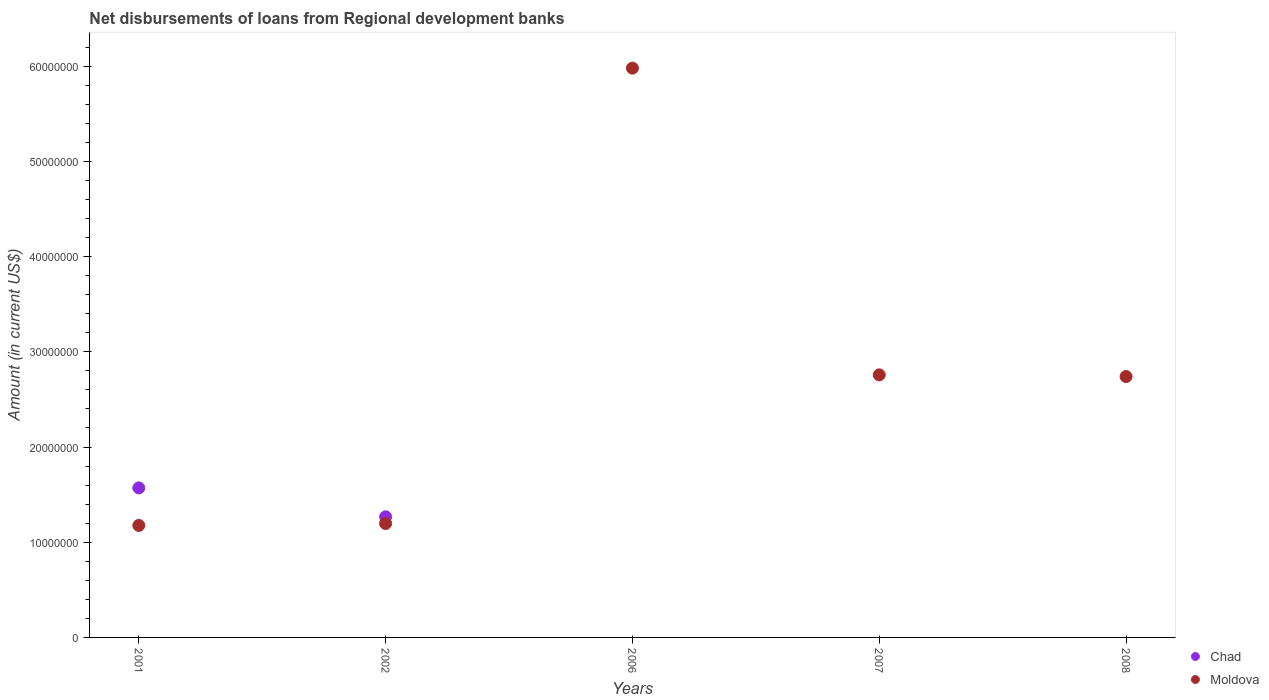Is the number of dotlines equal to the number of legend labels?
Your response must be concise. No. Across all years, what is the maximum amount of disbursements of loans from regional development banks in Moldova?
Your answer should be compact. 5.98e+07. Across all years, what is the minimum amount of disbursements of loans from regional development banks in Moldova?
Make the answer very short. 1.18e+07. What is the total amount of disbursements of loans from regional development banks in Moldova in the graph?
Your response must be concise. 1.39e+08. What is the difference between the amount of disbursements of loans from regional development banks in Chad in 2001 and that in 2002?
Give a very brief answer. 3.04e+06. What is the difference between the amount of disbursements of loans from regional development banks in Chad in 2006 and the amount of disbursements of loans from regional development banks in Moldova in 2002?
Offer a terse response. -1.20e+07. What is the average amount of disbursements of loans from regional development banks in Chad per year?
Ensure brevity in your answer.  5.68e+06. In the year 2002, what is the difference between the amount of disbursements of loans from regional development banks in Moldova and amount of disbursements of loans from regional development banks in Chad?
Your answer should be very brief. -7.05e+05. In how many years, is the amount of disbursements of loans from regional development banks in Moldova greater than 60000000 US$?
Your answer should be compact. 0. What is the ratio of the amount of disbursements of loans from regional development banks in Moldova in 2006 to that in 2007?
Provide a short and direct response. 2.17. Is the amount of disbursements of loans from regional development banks in Chad in 2001 less than that in 2002?
Your answer should be compact. No. What is the difference between the highest and the second highest amount of disbursements of loans from regional development banks in Moldova?
Provide a succinct answer. 3.22e+07. What is the difference between the highest and the lowest amount of disbursements of loans from regional development banks in Moldova?
Your answer should be compact. 4.80e+07. In how many years, is the amount of disbursements of loans from regional development banks in Moldova greater than the average amount of disbursements of loans from regional development banks in Moldova taken over all years?
Offer a terse response. 1. Is the sum of the amount of disbursements of loans from regional development banks in Moldova in 2001 and 2006 greater than the maximum amount of disbursements of loans from regional development banks in Chad across all years?
Provide a succinct answer. Yes. Does the amount of disbursements of loans from regional development banks in Chad monotonically increase over the years?
Offer a very short reply. No. Is the amount of disbursements of loans from regional development banks in Chad strictly greater than the amount of disbursements of loans from regional development banks in Moldova over the years?
Provide a short and direct response. No. How many dotlines are there?
Offer a very short reply. 2. What is the difference between two consecutive major ticks on the Y-axis?
Make the answer very short. 1.00e+07. Where does the legend appear in the graph?
Your answer should be compact. Bottom right. How many legend labels are there?
Your response must be concise. 2. How are the legend labels stacked?
Provide a succinct answer. Vertical. What is the title of the graph?
Your answer should be compact. Net disbursements of loans from Regional development banks. Does "Latin America(all income levels)" appear as one of the legend labels in the graph?
Offer a terse response. No. What is the label or title of the X-axis?
Offer a terse response. Years. What is the label or title of the Y-axis?
Your answer should be very brief. Amount (in current US$). What is the Amount (in current US$) in Chad in 2001?
Keep it short and to the point. 1.57e+07. What is the Amount (in current US$) of Moldova in 2001?
Give a very brief answer. 1.18e+07. What is the Amount (in current US$) of Chad in 2002?
Your answer should be very brief. 1.27e+07. What is the Amount (in current US$) in Moldova in 2002?
Your response must be concise. 1.20e+07. What is the Amount (in current US$) in Moldova in 2006?
Make the answer very short. 5.98e+07. What is the Amount (in current US$) in Chad in 2007?
Ensure brevity in your answer.  0. What is the Amount (in current US$) in Moldova in 2007?
Your response must be concise. 2.76e+07. What is the Amount (in current US$) of Chad in 2008?
Your answer should be compact. 0. What is the Amount (in current US$) of Moldova in 2008?
Ensure brevity in your answer.  2.74e+07. Across all years, what is the maximum Amount (in current US$) of Chad?
Offer a terse response. 1.57e+07. Across all years, what is the maximum Amount (in current US$) in Moldova?
Ensure brevity in your answer.  5.98e+07. Across all years, what is the minimum Amount (in current US$) of Moldova?
Offer a terse response. 1.18e+07. What is the total Amount (in current US$) in Chad in the graph?
Provide a short and direct response. 2.84e+07. What is the total Amount (in current US$) in Moldova in the graph?
Ensure brevity in your answer.  1.39e+08. What is the difference between the Amount (in current US$) of Chad in 2001 and that in 2002?
Provide a succinct answer. 3.04e+06. What is the difference between the Amount (in current US$) of Moldova in 2001 and that in 2002?
Make the answer very short. -2.02e+05. What is the difference between the Amount (in current US$) in Moldova in 2001 and that in 2006?
Give a very brief answer. -4.80e+07. What is the difference between the Amount (in current US$) in Moldova in 2001 and that in 2007?
Ensure brevity in your answer.  -1.58e+07. What is the difference between the Amount (in current US$) of Moldova in 2001 and that in 2008?
Keep it short and to the point. -1.56e+07. What is the difference between the Amount (in current US$) in Moldova in 2002 and that in 2006?
Your answer should be very brief. -4.78e+07. What is the difference between the Amount (in current US$) of Moldova in 2002 and that in 2007?
Provide a short and direct response. -1.56e+07. What is the difference between the Amount (in current US$) in Moldova in 2002 and that in 2008?
Your response must be concise. -1.54e+07. What is the difference between the Amount (in current US$) in Moldova in 2006 and that in 2007?
Offer a very short reply. 3.22e+07. What is the difference between the Amount (in current US$) in Moldova in 2006 and that in 2008?
Your answer should be very brief. 3.24e+07. What is the difference between the Amount (in current US$) of Moldova in 2007 and that in 2008?
Your answer should be compact. 1.74e+05. What is the difference between the Amount (in current US$) in Chad in 2001 and the Amount (in current US$) in Moldova in 2002?
Offer a very short reply. 3.74e+06. What is the difference between the Amount (in current US$) of Chad in 2001 and the Amount (in current US$) of Moldova in 2006?
Provide a succinct answer. -4.41e+07. What is the difference between the Amount (in current US$) in Chad in 2001 and the Amount (in current US$) in Moldova in 2007?
Your answer should be very brief. -1.19e+07. What is the difference between the Amount (in current US$) of Chad in 2001 and the Amount (in current US$) of Moldova in 2008?
Offer a very short reply. -1.17e+07. What is the difference between the Amount (in current US$) in Chad in 2002 and the Amount (in current US$) in Moldova in 2006?
Make the answer very short. -4.71e+07. What is the difference between the Amount (in current US$) in Chad in 2002 and the Amount (in current US$) in Moldova in 2007?
Offer a very short reply. -1.49e+07. What is the difference between the Amount (in current US$) of Chad in 2002 and the Amount (in current US$) of Moldova in 2008?
Give a very brief answer. -1.47e+07. What is the average Amount (in current US$) in Chad per year?
Provide a short and direct response. 5.68e+06. What is the average Amount (in current US$) of Moldova per year?
Provide a succinct answer. 2.77e+07. In the year 2001, what is the difference between the Amount (in current US$) in Chad and Amount (in current US$) in Moldova?
Offer a terse response. 3.94e+06. In the year 2002, what is the difference between the Amount (in current US$) of Chad and Amount (in current US$) of Moldova?
Ensure brevity in your answer.  7.05e+05. What is the ratio of the Amount (in current US$) in Chad in 2001 to that in 2002?
Your answer should be very brief. 1.24. What is the ratio of the Amount (in current US$) in Moldova in 2001 to that in 2002?
Provide a succinct answer. 0.98. What is the ratio of the Amount (in current US$) in Moldova in 2001 to that in 2006?
Provide a short and direct response. 0.2. What is the ratio of the Amount (in current US$) of Moldova in 2001 to that in 2007?
Offer a terse response. 0.43. What is the ratio of the Amount (in current US$) in Moldova in 2001 to that in 2008?
Your response must be concise. 0.43. What is the ratio of the Amount (in current US$) in Moldova in 2002 to that in 2006?
Give a very brief answer. 0.2. What is the ratio of the Amount (in current US$) of Moldova in 2002 to that in 2007?
Offer a very short reply. 0.43. What is the ratio of the Amount (in current US$) in Moldova in 2002 to that in 2008?
Ensure brevity in your answer.  0.44. What is the ratio of the Amount (in current US$) of Moldova in 2006 to that in 2007?
Keep it short and to the point. 2.17. What is the ratio of the Amount (in current US$) of Moldova in 2006 to that in 2008?
Your response must be concise. 2.18. What is the ratio of the Amount (in current US$) in Moldova in 2007 to that in 2008?
Keep it short and to the point. 1.01. What is the difference between the highest and the second highest Amount (in current US$) of Moldova?
Your answer should be very brief. 3.22e+07. What is the difference between the highest and the lowest Amount (in current US$) of Chad?
Offer a very short reply. 1.57e+07. What is the difference between the highest and the lowest Amount (in current US$) in Moldova?
Your answer should be compact. 4.80e+07. 